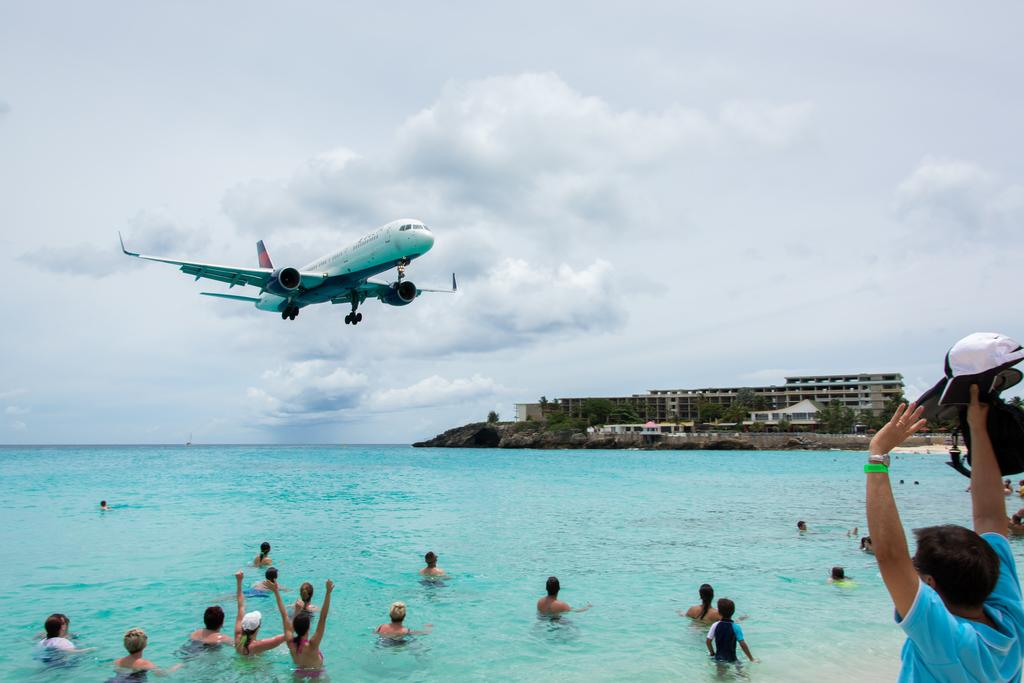What are the people in the image doing? The people in the image are in the water. What else can be seen in the sky in the image? There is a plane visible in the air. What type of structures are present in the image? There are buildings present in the image. What type of chairs can be seen in the image? There are no chairs present in the image. Is there any evidence of a war taking place in the image? There is no indication of a war in the image; it features people in the water, a plane in the air, and buildings. 